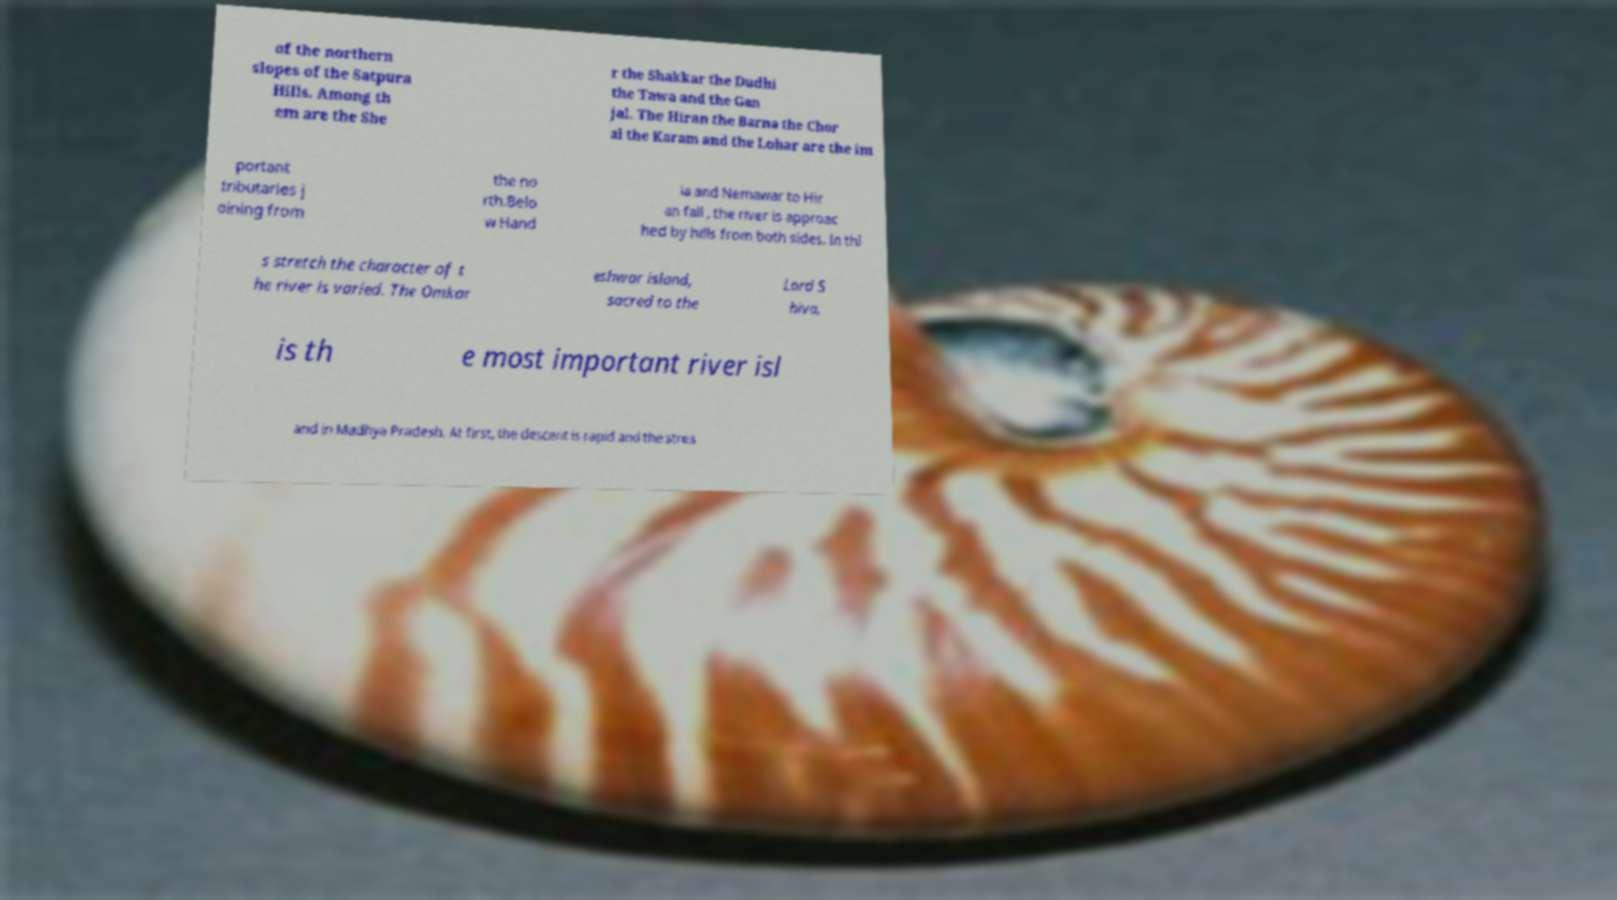Please identify and transcribe the text found in this image. of the northern slopes of the Satpura Hills. Among th em are the She r the Shakkar the Dudhi the Tawa and the Gan jal. The Hiran the Barna the Chor al the Karam and the Lohar are the im portant tributaries j oining from the no rth.Belo w Hand ia and Nemawar to Hir an fall , the river is approac hed by hills from both sides. In thi s stretch the character of t he river is varied. The Omkar eshwar island, sacred to the Lord S hiva, is th e most important river isl and in Madhya Pradesh. At first, the descent is rapid and the strea 